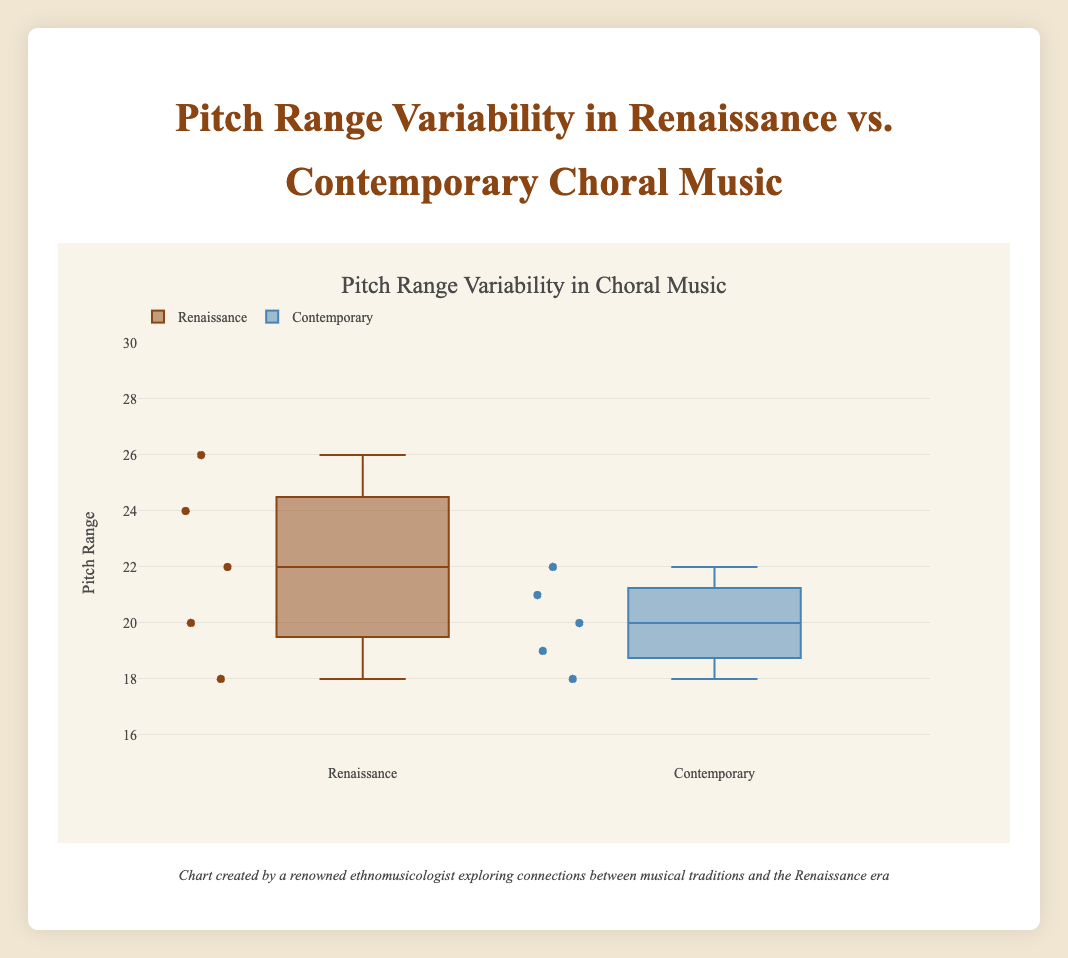what is the title of the plot? The title of the plot is located at the top of the figure and is formatted in a larger font size for clarity. Look at the text highlighted as the centerpiece of the plot.
Answer: Pitch Range Variability in Choral Music what are the five data points for the Renaissance era? To find the data points, look at the individual points plotted within the box plot for the Renaissance era, usually marked by distinct visual markers.
Answer: 22, 20, 24, 18, 26 what is the median pitch range for the contemporary era? The median is represented by the line inside the box of the contemporary era. It's the middle value when the numbers are arranged in ascending order.
Answer: 20 which era has the highest pitch range, and what is its value? The highest pitch range is the topmost point of the upper whisker in the box plot for both eras. Compare both eras to find the highest value.
Answer: Renaissance, 26 how does the average pitch range of Renaissance and Contemporary compare? Find each era's average by adding their pitch ranges and dividing by the count of works, then compare the two averages. Renaissance averages: (22 + 20 + 24 + 18 + 26) / 5 = 22, Contemporary averages: (20 + 22 + 18 + 21 + 19) / 5 = 20
Answer: Renaissance has a higher average pitch range identify the number of composers shown in the contemporary era. Look at the creative works listed under the contemporary era and count the unique composers.
Answer: 4 how does the interquartile range (IQR) of the Renaissance compare to that of the Contemporary era? The IQR is the distance between the first quartile (25th percentile) and the third quartile (75th percentile) of each era's box plot. Compare these values for the two eras.
Answer: Renaissance has a wider IQR than Contemporary which era shows more variability in pitch range? Variability can be assessed by the spread and length of the box and whiskers. The era with the broader range has higher variability.
Answer: Renaissance what is the smallest pitch range observed in the contemporary era? The smallest value is the lowest point of the lower whisker in the box plot for the contemporary era.
Answer: 18 what is the median pitch range of both eras combined? Combine all pitch ranges from both eras, order them, and find the median value of the total dataset. Data: 18, 18, 19, 20, 20, 21, 22, 22, 24, 26. Median of 10 values (middle two): (20+21)/2 = 20.5
Answer: 20.5 